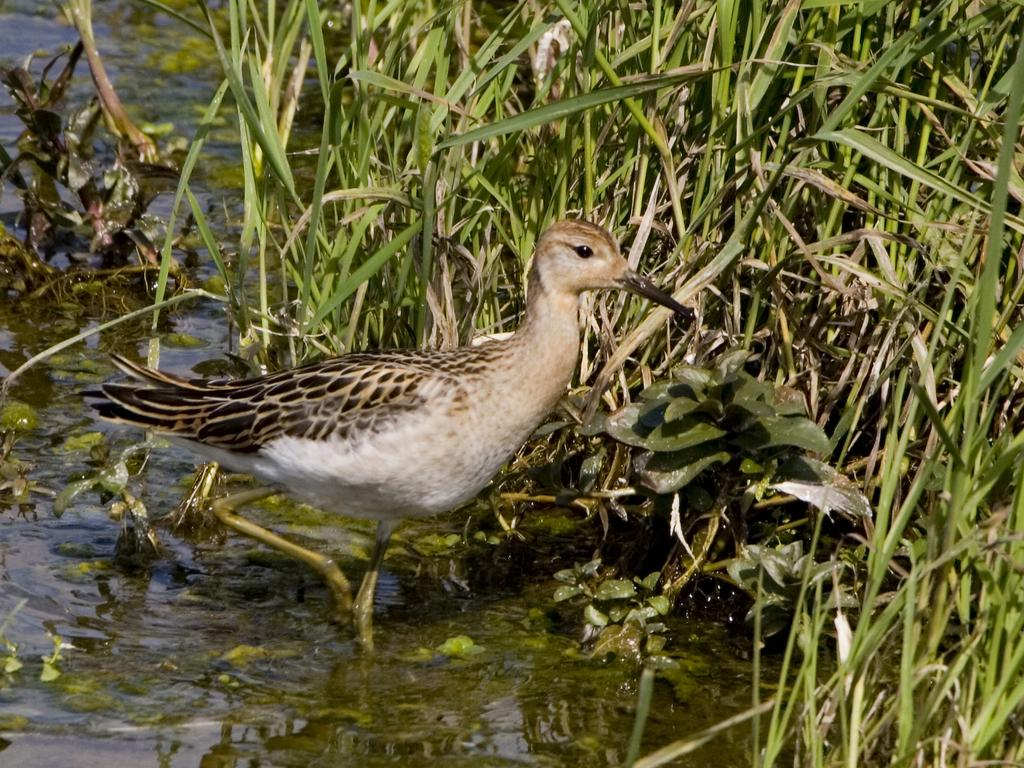What type of animal is in the image? There is a bird in the image. Where is the bird located? The bird is on water. What can be seen in the background of the image? There is grass visible in the background of the image. What type of property does the bird own in the image? There is no indication of the bird owning any property in the image. Can you hear a bell ringing in the image? There is no bell present in the image, so it cannot be heard. 